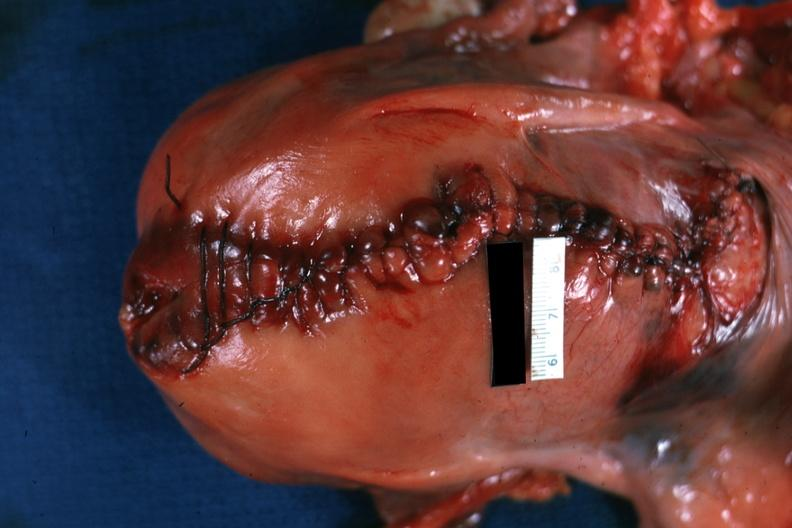s this image shows of smooth muscle cell with lipid in sarcoplasm and lipid present?
Answer the question using a single word or phrase. No 